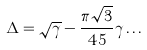<formula> <loc_0><loc_0><loc_500><loc_500>\Delta = \sqrt { \gamma } - \frac { \pi \sqrt { 3 } } { 4 5 } \gamma \dots</formula> 